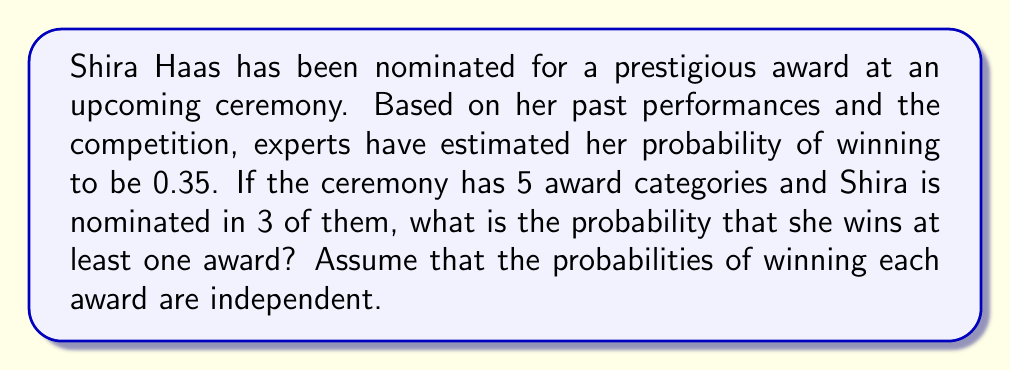Give your solution to this math problem. Let's approach this step-by-step:

1) First, we need to calculate the probability of Shira not winning a single award in a category she's nominated for. This is the complement of her winning probability:

   $P(\text{not winning one award}) = 1 - 0.35 = 0.65$

2) Now, for Shira to not win any award, she needs to not win in all 3 categories she's nominated for. Since the events are independent, we multiply these probabilities:

   $P(\text{not winning any award}) = 0.65 \times 0.65 \times 0.65 = 0.65^3 \approx 0.2746$

3) The probability of winning at least one award is the complement of not winning any award:

   $P(\text{winning at least one award}) = 1 - P(\text{not winning any award})$
   
   $= 1 - 0.2746 = 0.7254$

4) We can express this as a percentage:

   $0.7254 \times 100\% \approx 72.54\%$

Therefore, the probability of Shira Haas winning at least one award at this ceremony is approximately 72.54%.
Answer: $72.54\%$ 